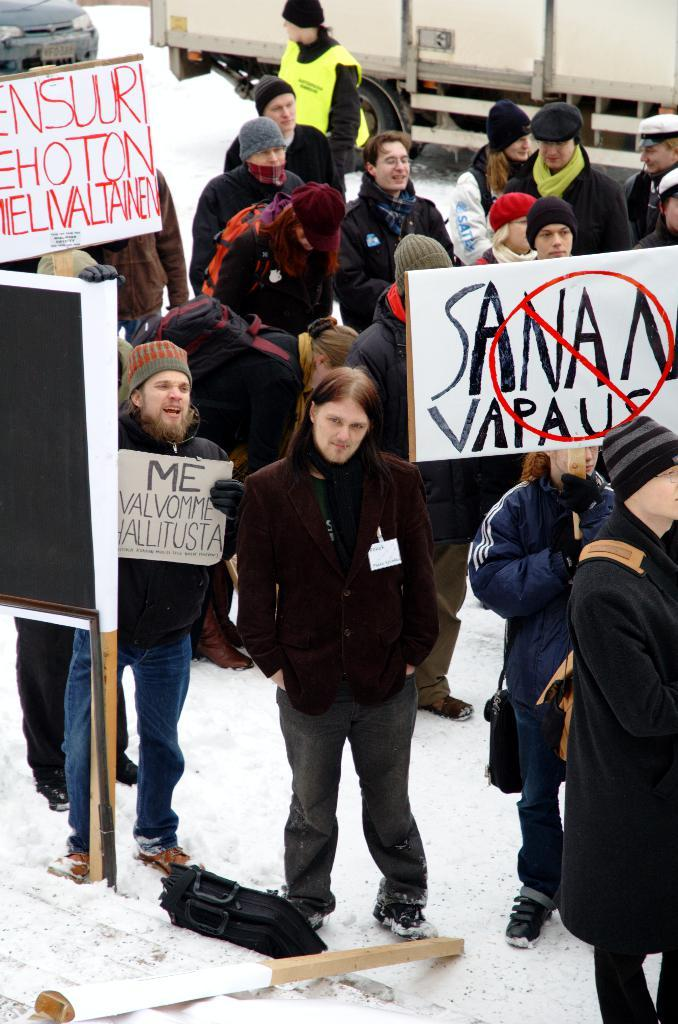What are the people in the image doing? The people in the image are standing and holding banners. What is the ground covered with in the image? There is snow on the ground in the image. What vehicles are present in the image? There is a truck and a car in the image. What type of quartz can be seen in the image? There is no quartz present in the image. What sport is being played in the image? There is no sport being played in the image; the people are holding banners. 